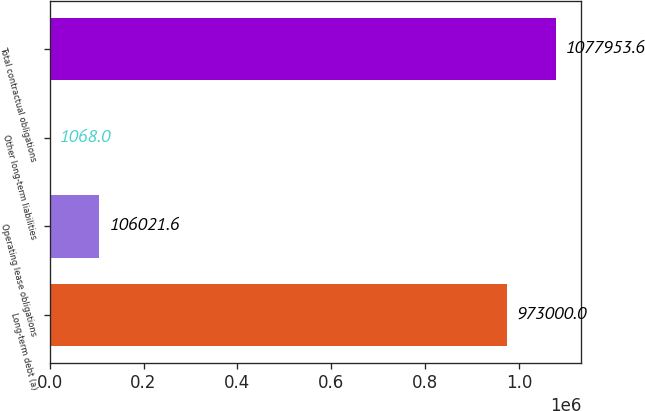Convert chart to OTSL. <chart><loc_0><loc_0><loc_500><loc_500><bar_chart><fcel>Long-term debt (a)<fcel>Operating lease obligations<fcel>Other long-term liabilities<fcel>Total contractual obligations<nl><fcel>973000<fcel>106022<fcel>1068<fcel>1.07795e+06<nl></chart> 